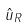<formula> <loc_0><loc_0><loc_500><loc_500>\hat { u } _ { R }</formula> 